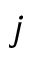<formula> <loc_0><loc_0><loc_500><loc_500>j</formula> 